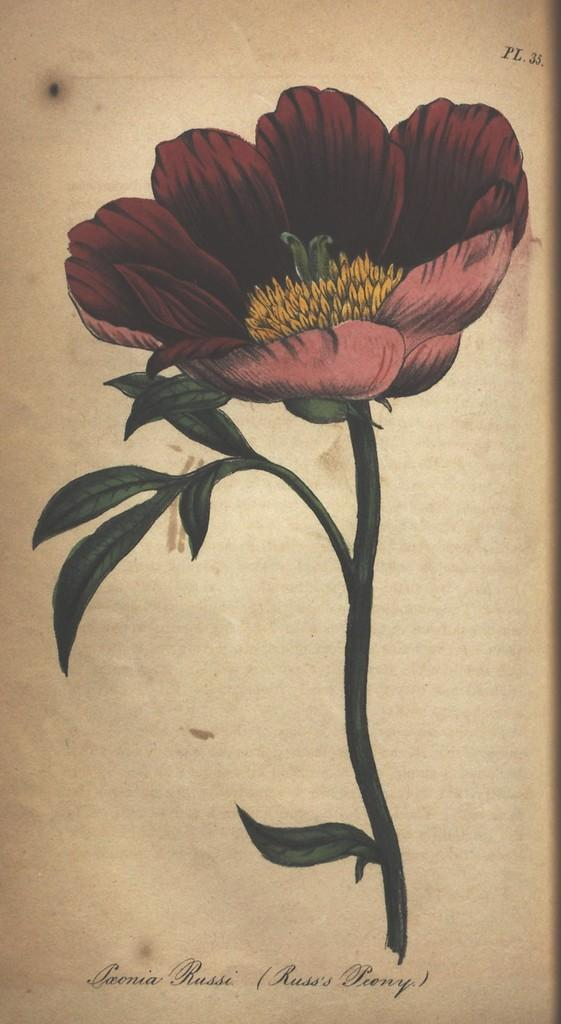What is depicted in the painting? The painting contains a plant. What specific features does the plant have? The plant has a flower and green leaves. Is there any text present in the painting? Yes, there is text at the bottom of the painting. Can you see any goats in the painting? No, there are no goats present in the painting. What color are the toes of the plant in the painting? Plants do not have toes, so this question cannot be answered. 